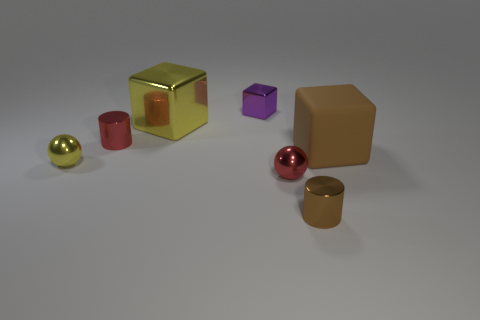The metallic object that is the same color as the large rubber block is what size?
Your response must be concise. Small. Is there a cylinder that has the same color as the large matte block?
Provide a short and direct response. Yes. What number of blocks are purple shiny objects or big yellow shiny objects?
Your response must be concise. 2. Is the number of big yellow shiny blocks greater than the number of yellow things?
Your answer should be very brief. No. How many brown blocks are the same size as the brown metallic cylinder?
Your answer should be very brief. 0. What shape is the other object that is the same color as the big matte object?
Offer a terse response. Cylinder. How many objects are either tiny cylinders in front of the brown block or tiny blue metallic cubes?
Provide a succinct answer. 1. Is the number of tiny objects less than the number of rubber spheres?
Offer a terse response. No. What shape is the large yellow object that is made of the same material as the red cylinder?
Provide a short and direct response. Cube. Are there any tiny shiny things in front of the brown rubber thing?
Keep it short and to the point. Yes. 